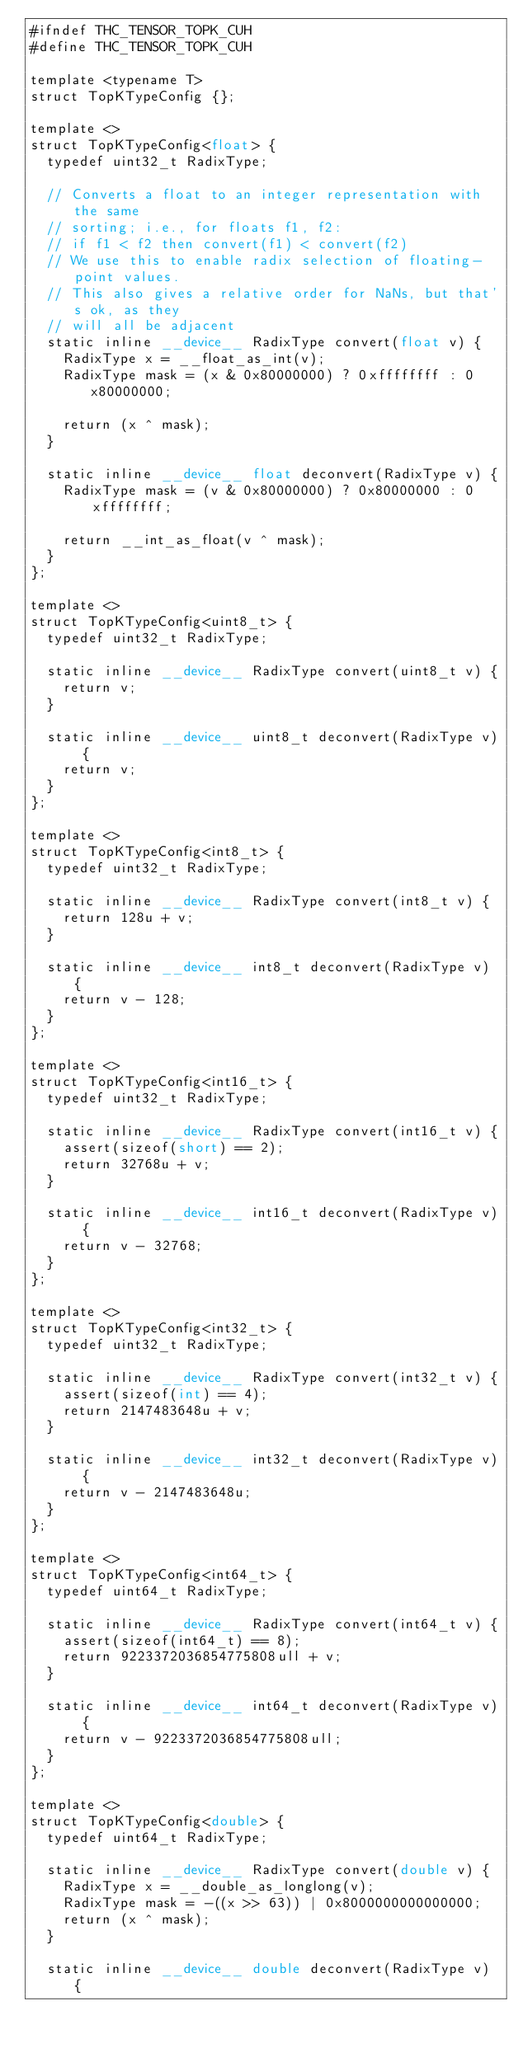Convert code to text. <code><loc_0><loc_0><loc_500><loc_500><_Cuda_>#ifndef THC_TENSOR_TOPK_CUH
#define THC_TENSOR_TOPK_CUH

template <typename T>
struct TopKTypeConfig {};

template <>
struct TopKTypeConfig<float> {
  typedef uint32_t RadixType;

  // Converts a float to an integer representation with the same
  // sorting; i.e., for floats f1, f2:
  // if f1 < f2 then convert(f1) < convert(f2)
  // We use this to enable radix selection of floating-point values.
  // This also gives a relative order for NaNs, but that's ok, as they
  // will all be adjacent
  static inline __device__ RadixType convert(float v) {
    RadixType x = __float_as_int(v);
    RadixType mask = (x & 0x80000000) ? 0xffffffff : 0x80000000;

    return (x ^ mask);
  }

  static inline __device__ float deconvert(RadixType v) {
    RadixType mask = (v & 0x80000000) ? 0x80000000 : 0xffffffff;

    return __int_as_float(v ^ mask);
  }
};

template <>
struct TopKTypeConfig<uint8_t> {
  typedef uint32_t RadixType;

  static inline __device__ RadixType convert(uint8_t v) {
    return v;
  }

  static inline __device__ uint8_t deconvert(RadixType v) {
    return v;
  }
};

template <>
struct TopKTypeConfig<int8_t> {
  typedef uint32_t RadixType;

  static inline __device__ RadixType convert(int8_t v) {
    return 128u + v;
  }

  static inline __device__ int8_t deconvert(RadixType v) {
    return v - 128;
  }
};

template <>
struct TopKTypeConfig<int16_t> {
  typedef uint32_t RadixType;

  static inline __device__ RadixType convert(int16_t v) {
    assert(sizeof(short) == 2);
    return 32768u + v;
  }

  static inline __device__ int16_t deconvert(RadixType v) {
    return v - 32768;
  }
};

template <>
struct TopKTypeConfig<int32_t> {
  typedef uint32_t RadixType;

  static inline __device__ RadixType convert(int32_t v) {
    assert(sizeof(int) == 4);
    return 2147483648u + v;
  }

  static inline __device__ int32_t deconvert(RadixType v) {
    return v - 2147483648u;
  }
};

template <>
struct TopKTypeConfig<int64_t> {
  typedef uint64_t RadixType;

  static inline __device__ RadixType convert(int64_t v) {
    assert(sizeof(int64_t) == 8);
    return 9223372036854775808ull + v;
  }

  static inline __device__ int64_t deconvert(RadixType v) {
    return v - 9223372036854775808ull;
  }
};

template <>
struct TopKTypeConfig<double> {
  typedef uint64_t RadixType;

  static inline __device__ RadixType convert(double v) {
    RadixType x = __double_as_longlong(v);
    RadixType mask = -((x >> 63)) | 0x8000000000000000;
    return (x ^ mask);
  }

  static inline __device__ double deconvert(RadixType v) {</code> 